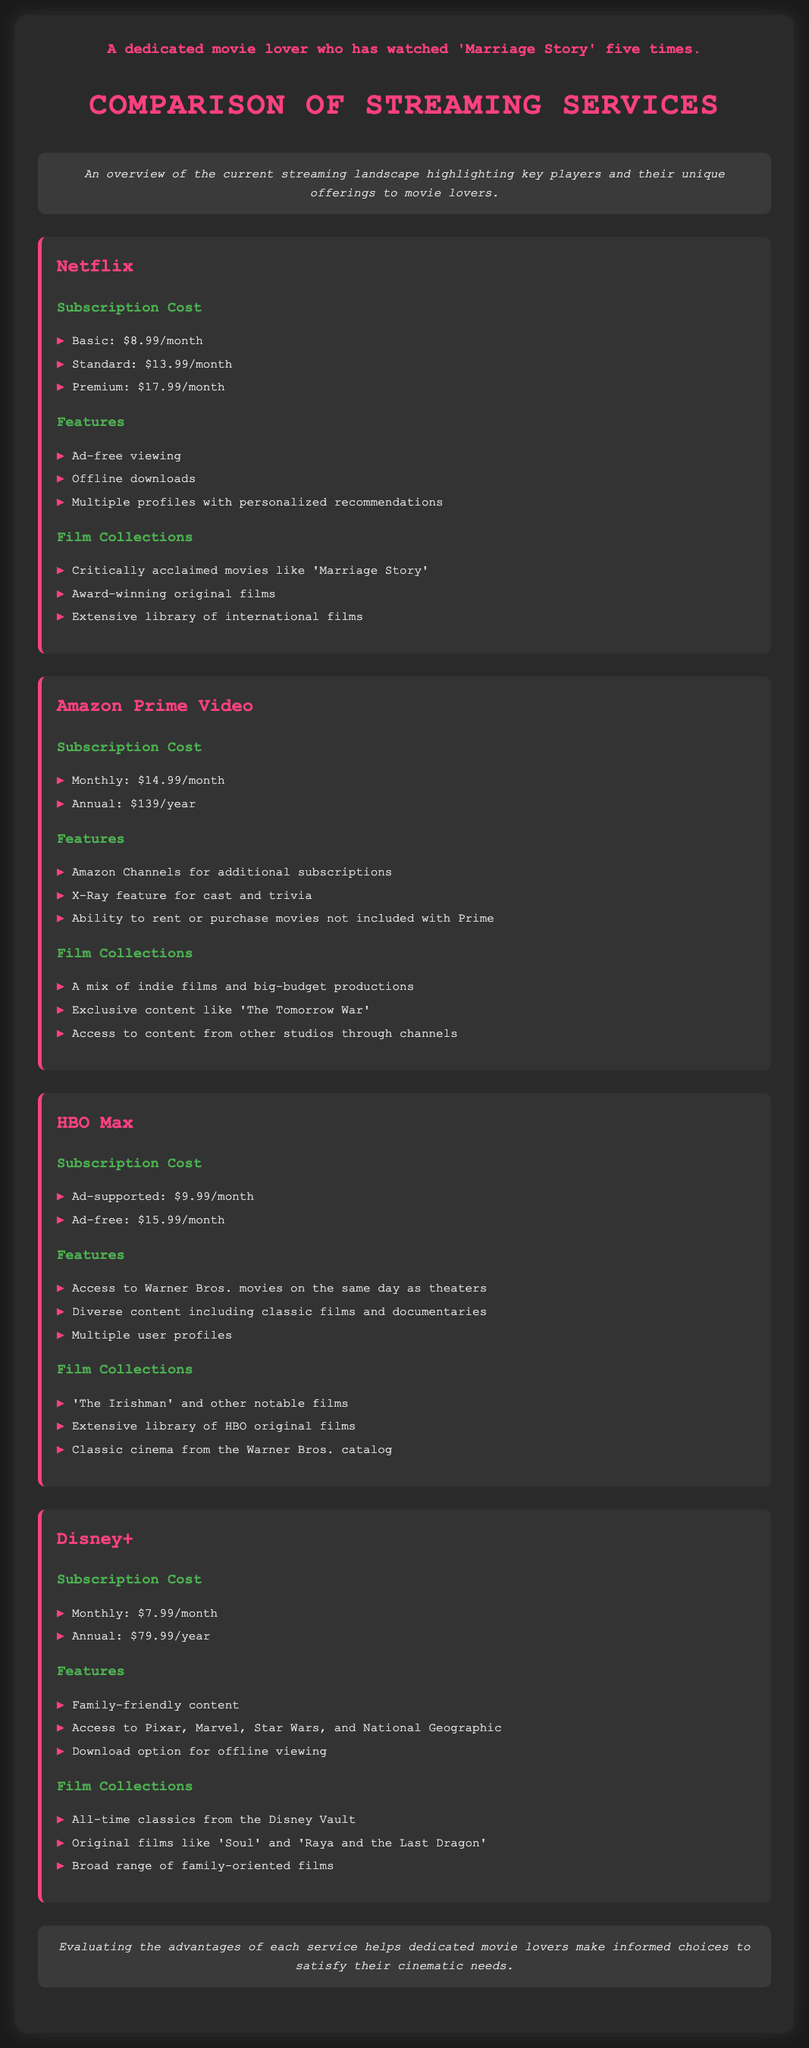What is the monthly cost of Netflix's Basic plan? The document states that the Basic plan costs $8.99/month.
Answer: $8.99/month Which feature is exclusive to Amazon Prime Video? The document lists the X-Ray feature for cast and trivia as a unique offering for Amazon Prime Video.
Answer: X-Ray feature What is the annual subscription cost for Disney+? The document specifies that the annual subscription for Disney+ is $79.99/year.
Answer: $79.99/year Name one critically acclaimed movie available on Netflix. The document mentions 'Marriage Story' as a critically acclaimed film available on Netflix.
Answer: Marriage Story How many subscription options does HBO Max offer? The document outlines two subscription options: ad-supported and ad-free, totaling two options.
Answer: 2 What type of content is emphasized in Disney+'s film collection? The document highlights that Disney+ focuses on family-friendly content in its film collection.
Answer: Family-friendly content What is the maximum subscription cost for Netflix? The document lists the Premium plan of Netflix as the highest subscription option at $17.99/month.
Answer: $17.99/month List a feature that all four streaming services provide. The document suggests that multiple user profiles are a common feature available in HBO Max and Netflix, among others.
Answer: Multiple profiles Which service offers offline downloads? The document indicates that Netflix, Disney+, and HBO Max provide offline downloads as a feature.
Answer: Netflix, Disney+, HBO Max 